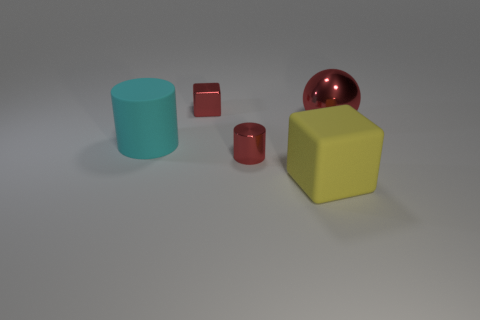There is a metallic thing in front of the big red metal object; what color is it?
Make the answer very short. Red. There is a small shiny thing in front of the tiny red cube; are there any red shiny things on the left side of it?
Provide a short and direct response. Yes. What number of things are shiny things left of the red ball or blocks?
Offer a very short reply. 3. The big thing to the left of the tiny shiny thing that is behind the rubber cylinder is made of what material?
Your answer should be very brief. Rubber. Is the number of red metallic objects that are left of the tiny red metallic cylinder the same as the number of small red metallic things that are in front of the big red metallic sphere?
Offer a terse response. Yes. What number of objects are either shiny things that are to the left of the yellow rubber thing or metal objects to the right of the matte cube?
Offer a very short reply. 3. There is a thing that is both left of the small shiny cylinder and behind the large matte cylinder; what material is it?
Offer a terse response. Metal. What is the size of the metal object in front of the matte thing on the left side of the big matte object in front of the cyan cylinder?
Provide a short and direct response. Small. Are there more big yellow cubes than tiny yellow matte cylinders?
Keep it short and to the point. Yes. Is the red thing that is right of the big yellow thing made of the same material as the red cylinder?
Make the answer very short. Yes. 